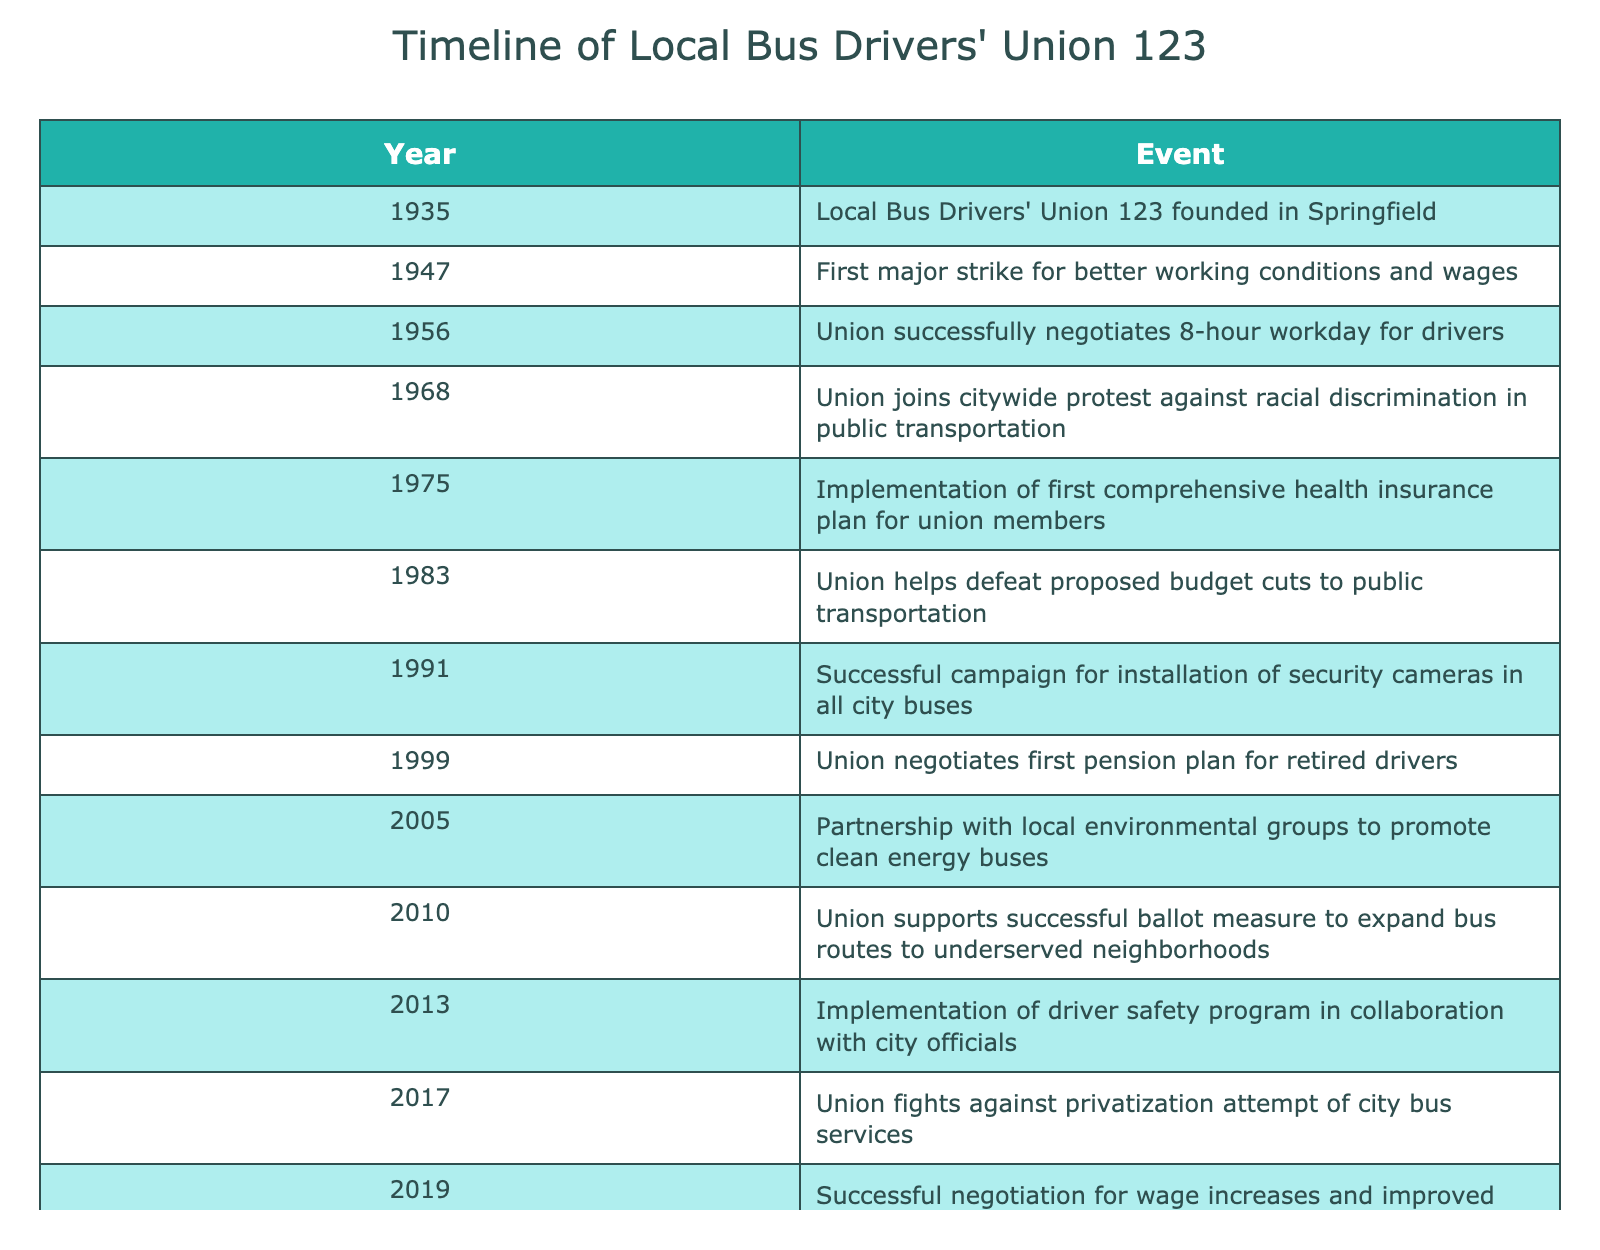What year was the Local Bus Drivers' Union 123 founded? The table states that the union was founded in 1935. We can find this by looking at the first row under the "Year" column.
Answer: 1935 What significant event related to working conditions occurred in 1947? The table indicates that in 1947, there was the first major strike for better working conditions and wages. This is detailed in the second row of the table under the "Event" column.
Answer: First major strike for better working conditions and wages In which year did the union negotiate an 8-hour workday for drivers? According to the table, the union successfully negotiated an 8-hour workday for drivers in 1956. This information is available in the third row under the "Year" and "Event" columns.
Answer: 1956 How many major events occurred before 2000? By reviewing the table, we can count the events listed from the first entry in 1935 up to the last entry before 2000, which is from 1935 to 1999. There are 9 events in total before the year 2000, as listed in the table.
Answer: 9 Did the union ever support a ballot measure? The table shows a successful ballot measure to expand bus routes to underserved neighborhoods in 2010, indicating that the union did support a ballot measure. We can see this event clearly stated in the relevant row under the "Year" and "Event" columns.
Answer: Yes Which event signifies the union's support for public health during the COVID-19 pandemic? The table notes that in 2021, the union played a key role in the city's COVID-19 vaccination program for essential workers, highlighting their involvement in public health during this period. This can be found in the entry for 2021 under the "Event" column.
Answer: Union's key role in COVID-19 vaccination program What was the first event that addressed health benefits for union members? The table indicates that in 1975, the implementation of the first comprehensive health insurance plan for union members took place. This can be identified in the fifth row of the table under the "Year" and "Event" columns.
Answer: 1975 How many events are related to financial negotiations (wages and pensions)? By examining the table, two events specifically pertain to financial negotiations: the successful negotiation for wage increases and improved working conditions in 2019, and the negotiation of the first pension plan for retired drivers in 1999. This gives us a total of 2 events related to financial negotiations.
Answer: 2 List the years that include social justice movements associated with the union. The table outlines two key social justice events: in 1968, the union joined a citywide protest against racial discrimination in public transportation; and in 2017, the union fought against a privatization attempt of city bus services. These years, thus, are 1968 and 2017, indicating active social justice movements associated with the union.
Answer: 1968, 2017 